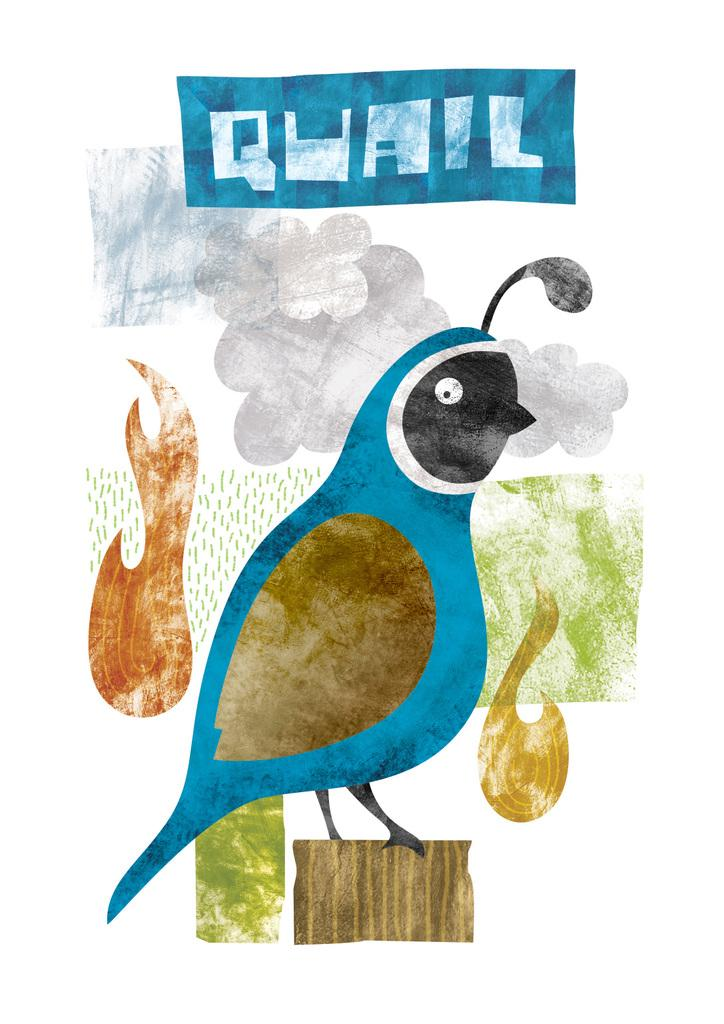What is depicted in the drawing in the image? There is a drawing of a bird in the image. What can be seen in the sky in the image? There are clouds in the sky in the image. What is written at the top of the image? There is text written at the top of the image. Can you see a flame in the image? No, there is no flame present in the image. Is the bird drawing located at the seashore in the image? The provided facts do not mention a seashore, so we cannot determine if the bird drawing is located at the seashore. 